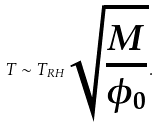Convert formula to latex. <formula><loc_0><loc_0><loc_500><loc_500>T \sim T _ { R H } \sqrt { \frac { M } { \phi _ { 0 } } } .</formula> 